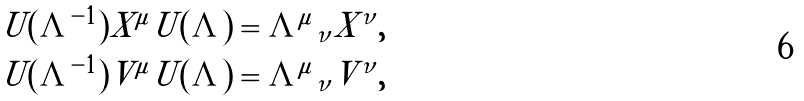<formula> <loc_0><loc_0><loc_500><loc_500>U ( \varLambda ^ { - 1 } ) X ^ { \mu } U ( \varLambda ) & = { \varLambda ^ { \mu } } _ { \nu } X ^ { \nu } , \\ U ( \varLambda ^ { - 1 } ) V ^ { \mu } U ( \varLambda ) & = { \varLambda ^ { \mu } } _ { \nu } V ^ { \nu } ,</formula> 